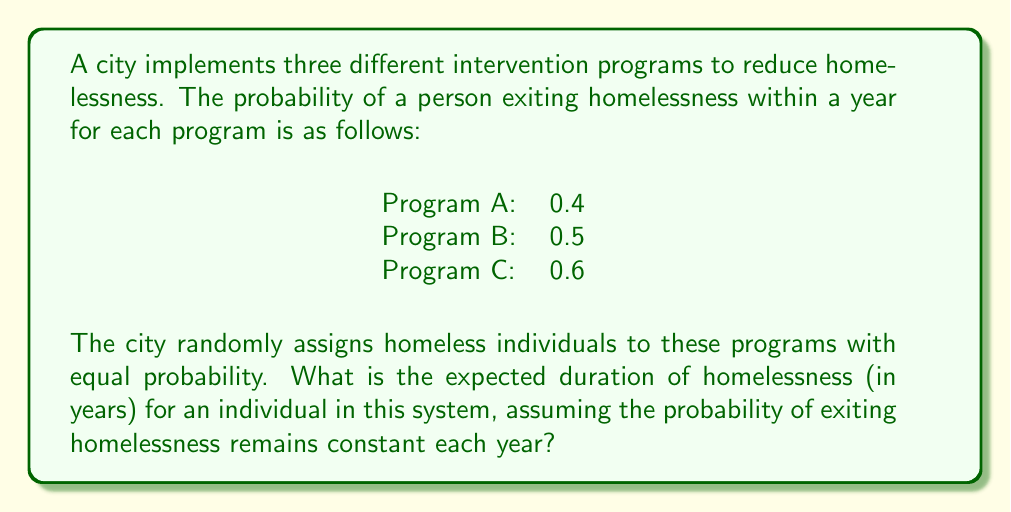Can you answer this question? To solve this problem, we'll follow these steps:

1) First, we need to calculate the overall probability of exiting homelessness in a given year.

   Let $X$ be the random variable representing the program assigned.
   Let $Y$ be the random variable representing whether a person exits homelessness in a year.

   $P(Y=1|X=A) = 0.4$
   $P(Y=1|X=B) = 0.5$
   $P(Y=1|X=C) = 0.6$

   $P(X=A) = P(X=B) = P(X=C) = \frac{1}{3}$

   Using the law of total probability:
   
   $$P(Y=1) = P(Y=1|X=A)P(X=A) + P(Y=1|X=B)P(X=B) + P(Y=1|X=C)P(X=C)$$
   
   $$P(Y=1) = 0.4 \cdot \frac{1}{3} + 0.5 \cdot \frac{1}{3} + 0.6 \cdot \frac{1}{3} = \frac{0.4 + 0.5 + 0.6}{3} = 0.5$$

2) The probability of exiting homelessness in a given year is 0.5, so the probability of remaining homeless is 1 - 0.5 = 0.5.

3) This scenario follows a geometric distribution, where we're interested in the expected number of trials (years) until success (exiting homelessness).

4) For a geometric distribution with probability of success $p$, the expected value is $\frac{1}{p}$.

5) Therefore, the expected duration of homelessness is:

   $$E(\text{duration}) = \frac{1}{p} = \frac{1}{0.5} = 2 \text{ years}$$

Thus, the expected duration of homelessness for an individual in this system is 2 years.
Answer: 2 years 